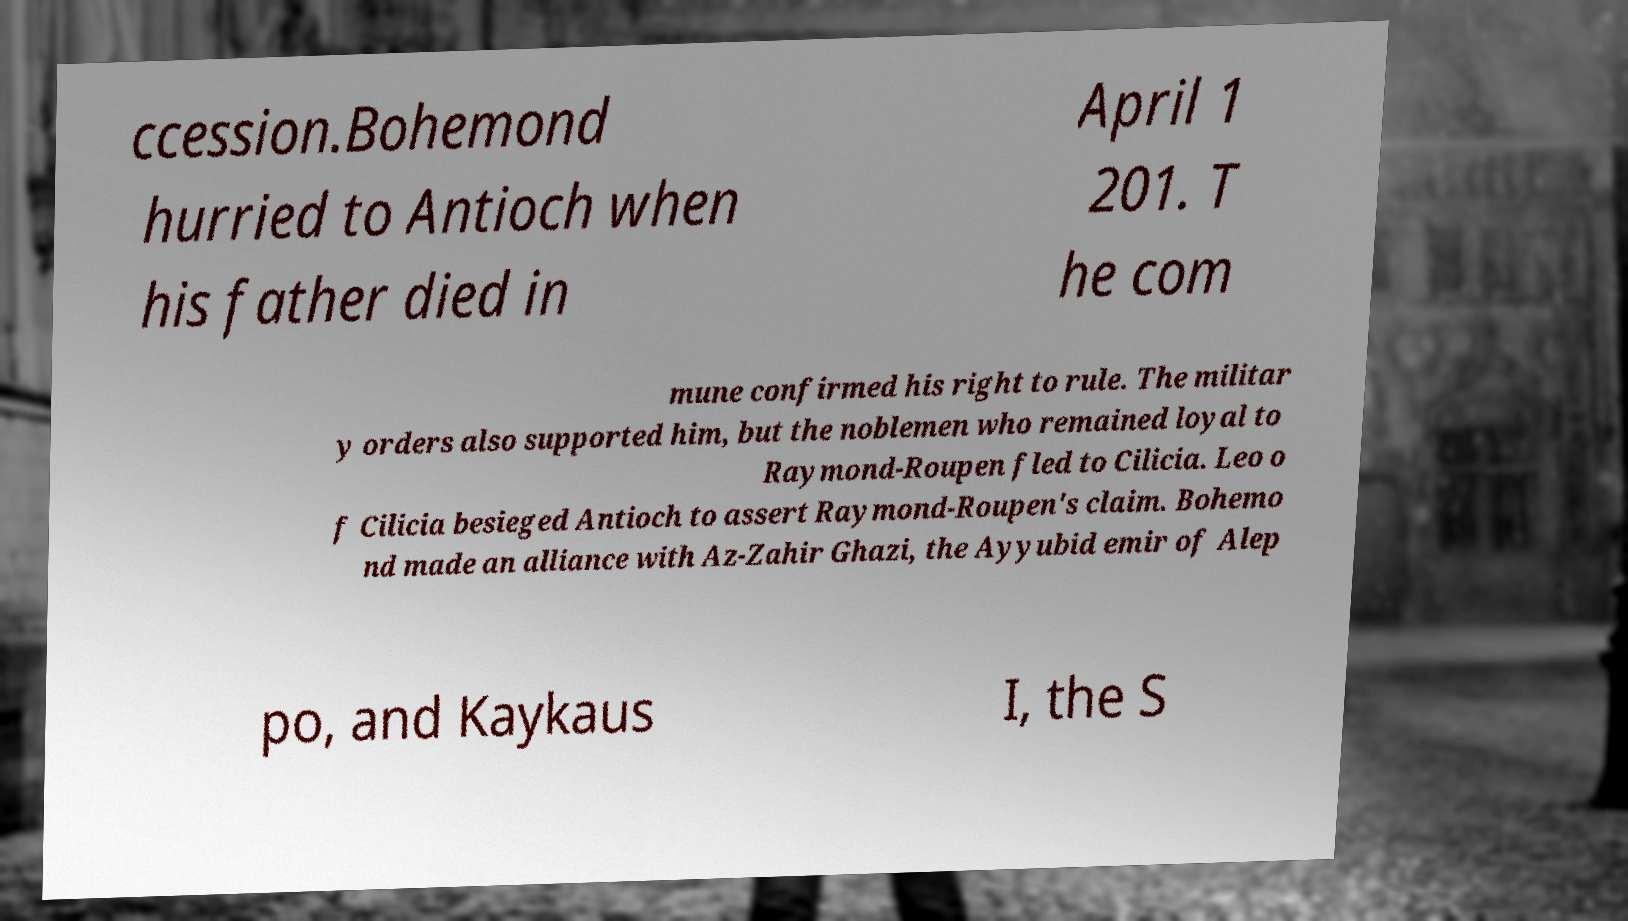Please read and relay the text visible in this image. What does it say? ccession.Bohemond hurried to Antioch when his father died in April 1 201. T he com mune confirmed his right to rule. The militar y orders also supported him, but the noblemen who remained loyal to Raymond-Roupen fled to Cilicia. Leo o f Cilicia besieged Antioch to assert Raymond-Roupen's claim. Bohemo nd made an alliance with Az-Zahir Ghazi, the Ayyubid emir of Alep po, and Kaykaus I, the S 